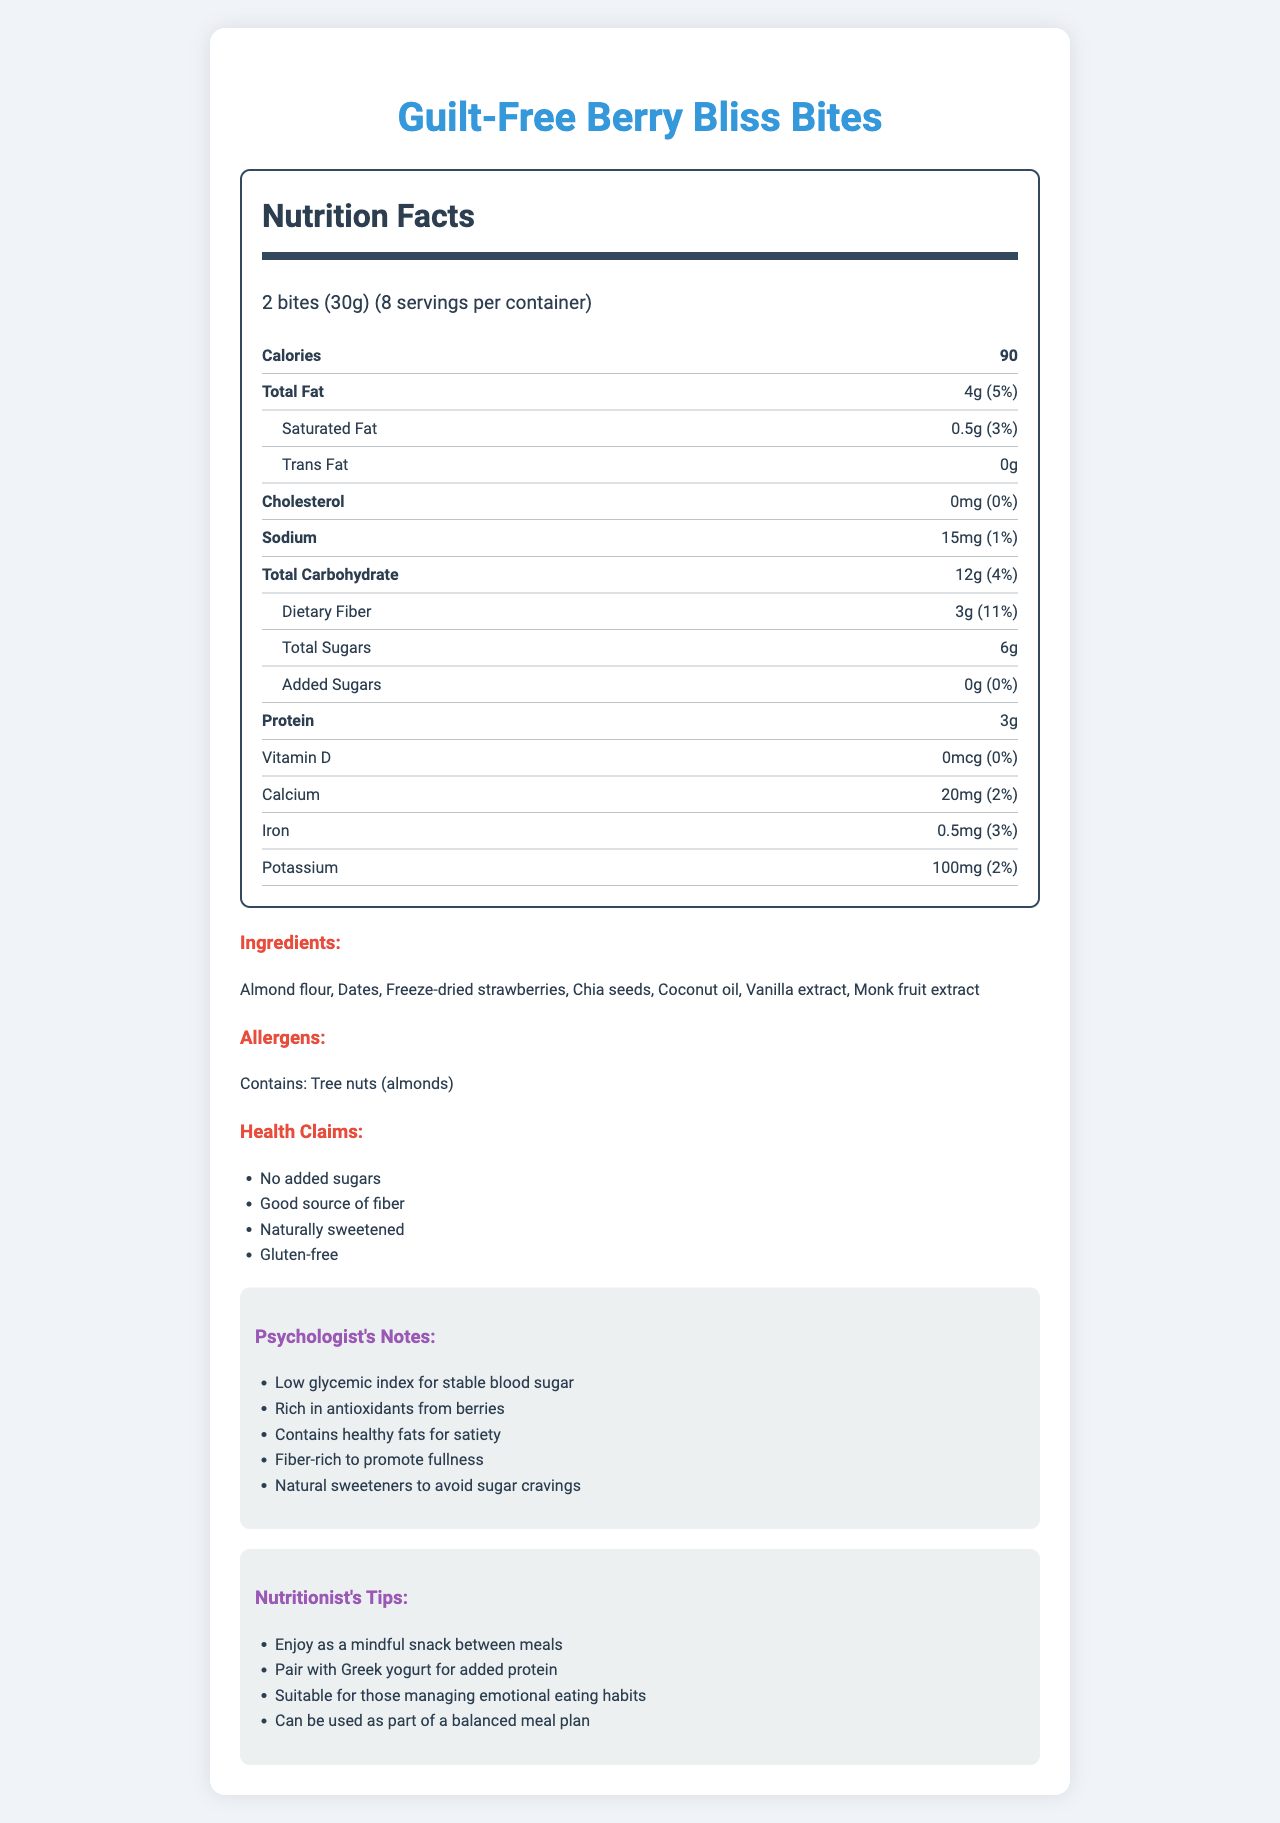what is the serving size? The serving size information is displayed under "Nutrition Facts" and states "2 bites (30g)".
Answer: 2 bites (30g) how many calories are in one serving? The calories per serving are clearly mentioned at the top of the nutrition label section.
Answer: 90 how much dietary fiber is in one serving? The dietary fiber content is listed under the "Total Carbohydrate" section with the amount and daily value percentage.
Answer: 3g what are the main ingredients of Guilt-Free Berry Bliss Bites? The main ingredients are listed under the "Ingredients" section.
Answer: Almond flour, Dates, Freeze-dried strawberries, Chia seeds, Coconut oil, Vanilla extract, Monk fruit extract is this product suitable for someone who is gluten intolerant? One of the health claims states that the product is "Gluten-free", which indicates it is suitable for those who are gluten intolerant.
Answer: Yes does this product contain any trans fat? The amount of trans fat is listed as 0g in the "Total Fat" section.
Answer: No does this product contain any added sugars? The "Total Sugars" section mentions "Added Sugars: 0g (0%)", indicating no added sugars.
Answer: No summarize the main features of Guilt-Free Berry Bliss Bites. The summary covers the main health benefits and the nutrient content, emphasizing the natural ingredients and their effects on health.
Answer: Guilt-Free Berry Bliss Bites are a low-calorie, gluten-free dessert alternative featuring natural sweeteners like monk fruit extract. They contain beneficial nutrients, including 3g of dietary fiber and 3g of protein per serving, and are free from added sugars and trans fats. The product is rich in antioxidants from berries and contains healthy fats from ingredients like almond flour and chia seeds. how many servings per container are there? The servings per container are specified in the serving information section.
Answer: 8 which vitamins and minerals are included in the nutrition facts? The vitamins and minerals included are displayed towards the bottom of the nutrition label section.
Answer: Vitamin D, Calcium, Iron, Potassium is this product rich in antioxidants? The Psychologist's Notes mention that the product is "Rich in antioxidants from berries."
Answer: Yes how much sodium is in one serving? The sodium content is listed in the middle of the nutrition label section.
Answer: 15mg which ingredient is used as a natural sweetener? The ingredients list includes "Monk fruit extract" as a natural sweetener.
Answer: Monk fruit extract is this product recommended for managing emotional eating habits? The Nutritionist's Tips include that it is "Suitable for those managing emotional eating habits."
Answer: Yes what is the recommended way to enjoy these bites as suggested by the nutritionist? The Nutritionist's Tips section provides recommendations on how to include the bites in one's diet.
Answer: Enjoy as a mindful snack between meals, Pair with Greek yogurt for added protein, Can be used as part of a balanced meal plan how much calcium is in one serving? The amount of calcium per serving is listed towards the bottom of the nutrition label section.
Answer: 20mg describe the psychologist's perspective on this product in terms of its benefits for emotional eating. This detailed explanation combines all points listed under the "Psychologist's Notes" to describe the benefits for managing emotional eating.
Answer: This product is designed to help manage emotional eating by providing a low glycemic index for stable blood sugar, rich antioxidants from berries, healthy fats for satiety, and fiber to promote fullness. The use of natural sweeteners avoids sugar cravings. what flavoring is used in this product? The ingredients list includes "Vanilla extract" as a flavoring component.
Answer: Vanilla extract how is the product naturally sweetened? The ingredients list features monk fruit extract and dates, both known for their natural sweetness.
Answer: The product is naturally sweetened with monk fruit extract and dates. how does the fiber content of Guilt-Free Berry Bliss Bites promote fullness? Fiber helps maintain a feeling of fullness and can regulate blood sugar levels, making it beneficial for managing hunger and preventing overeating.
Answer: The high dietary fiber content (3g per serving) helps promote fullness and satiety by slowing down digestion and stabilizing blood sugar levels. 